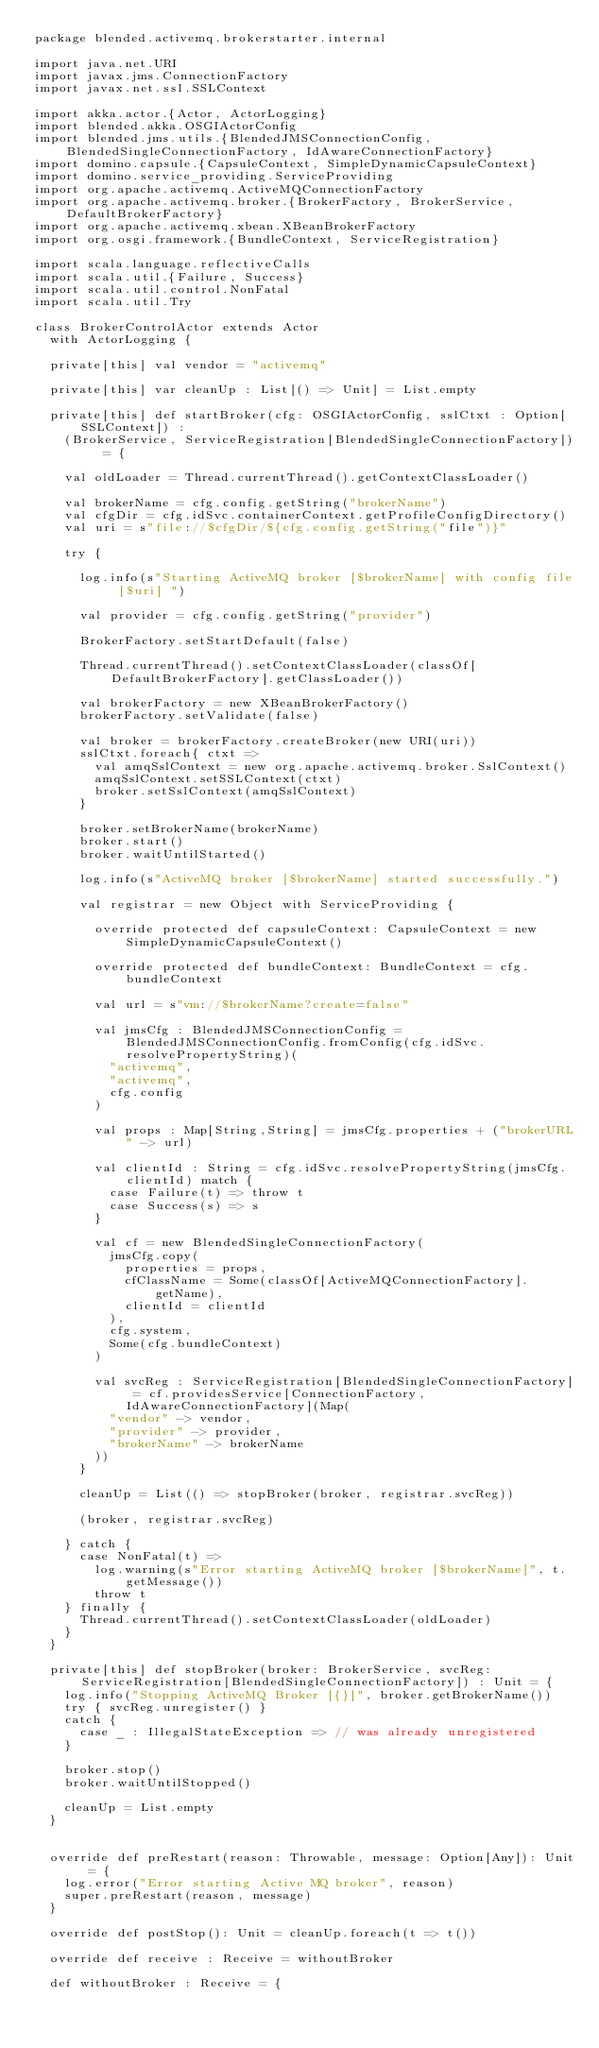<code> <loc_0><loc_0><loc_500><loc_500><_Scala_>package blended.activemq.brokerstarter.internal

import java.net.URI
import javax.jms.ConnectionFactory
import javax.net.ssl.SSLContext

import akka.actor.{Actor, ActorLogging}
import blended.akka.OSGIActorConfig
import blended.jms.utils.{BlendedJMSConnectionConfig, BlendedSingleConnectionFactory, IdAwareConnectionFactory}
import domino.capsule.{CapsuleContext, SimpleDynamicCapsuleContext}
import domino.service_providing.ServiceProviding
import org.apache.activemq.ActiveMQConnectionFactory
import org.apache.activemq.broker.{BrokerFactory, BrokerService, DefaultBrokerFactory}
import org.apache.activemq.xbean.XBeanBrokerFactory
import org.osgi.framework.{BundleContext, ServiceRegistration}

import scala.language.reflectiveCalls
import scala.util.{Failure, Success}
import scala.util.control.NonFatal
import scala.util.Try

class BrokerControlActor extends Actor
  with ActorLogging {

  private[this] val vendor = "activemq"

  private[this] var cleanUp : List[() => Unit] = List.empty

  private[this] def startBroker(cfg: OSGIActorConfig, sslCtxt : Option[SSLContext]) :
    (BrokerService, ServiceRegistration[BlendedSingleConnectionFactory]) = {

    val oldLoader = Thread.currentThread().getContextClassLoader()

    val brokerName = cfg.config.getString("brokerName")
    val cfgDir = cfg.idSvc.containerContext.getProfileConfigDirectory()
    val uri = s"file://$cfgDir/${cfg.config.getString("file")}"

    try {

      log.info(s"Starting ActiveMQ broker [$brokerName] with config file [$uri] ")

      val provider = cfg.config.getString("provider")

      BrokerFactory.setStartDefault(false)

      Thread.currentThread().setContextClassLoader(classOf[DefaultBrokerFactory].getClassLoader())

      val brokerFactory = new XBeanBrokerFactory()
      brokerFactory.setValidate(false)

      val broker = brokerFactory.createBroker(new URI(uri))
      sslCtxt.foreach{ ctxt =>
        val amqSslContext = new org.apache.activemq.broker.SslContext()
        amqSslContext.setSSLContext(ctxt)
        broker.setSslContext(amqSslContext)
      }

      broker.setBrokerName(brokerName)
      broker.start()
      broker.waitUntilStarted()

      log.info(s"ActiveMQ broker [$brokerName] started successfully.")

      val registrar = new Object with ServiceProviding {

        override protected def capsuleContext: CapsuleContext = new SimpleDynamicCapsuleContext()

        override protected def bundleContext: BundleContext = cfg.bundleContext

        val url = s"vm://$brokerName?create=false"

        val jmsCfg : BlendedJMSConnectionConfig = BlendedJMSConnectionConfig.fromConfig(cfg.idSvc.resolvePropertyString)(
          "activemq",
          "activemq",
          cfg.config
        )

        val props : Map[String,String] = jmsCfg.properties + ("brokerURL" -> url)

        val clientId : String = cfg.idSvc.resolvePropertyString(jmsCfg.clientId) match {
          case Failure(t) => throw t
          case Success(s) => s
        }

        val cf = new BlendedSingleConnectionFactory(
          jmsCfg.copy(
            properties = props,
            cfClassName = Some(classOf[ActiveMQConnectionFactory].getName),
            clientId = clientId
          ),
          cfg.system,
          Some(cfg.bundleContext)
        )

        val svcReg : ServiceRegistration[BlendedSingleConnectionFactory] = cf.providesService[ConnectionFactory, IdAwareConnectionFactory](Map(
          "vendor" -> vendor,
          "provider" -> provider,
          "brokerName" -> brokerName
        ))
      }

      cleanUp = List(() => stopBroker(broker, registrar.svcReg))

      (broker, registrar.svcReg)

    } catch {
      case NonFatal(t) =>
        log.warning(s"Error starting ActiveMQ broker [$brokerName]", t.getMessage())
        throw t
    } finally {
      Thread.currentThread().setContextClassLoader(oldLoader)
    }
  }

  private[this] def stopBroker(broker: BrokerService, svcReg: ServiceRegistration[BlendedSingleConnectionFactory]) : Unit = {
    log.info("Stopping ActiveMQ Broker [{}]", broker.getBrokerName())
    try { svcReg.unregister() }
    catch {
      case _ : IllegalStateException => // was already unregistered
    }

    broker.stop()
    broker.waitUntilStopped()

    cleanUp = List.empty
  }


  override def preRestart(reason: Throwable, message: Option[Any]): Unit = {
    log.error("Error starting Active MQ broker", reason)
    super.preRestart(reason, message)
  }

  override def postStop(): Unit = cleanUp.foreach(t => t())

  override def receive : Receive = withoutBroker

  def withoutBroker : Receive = {</code> 